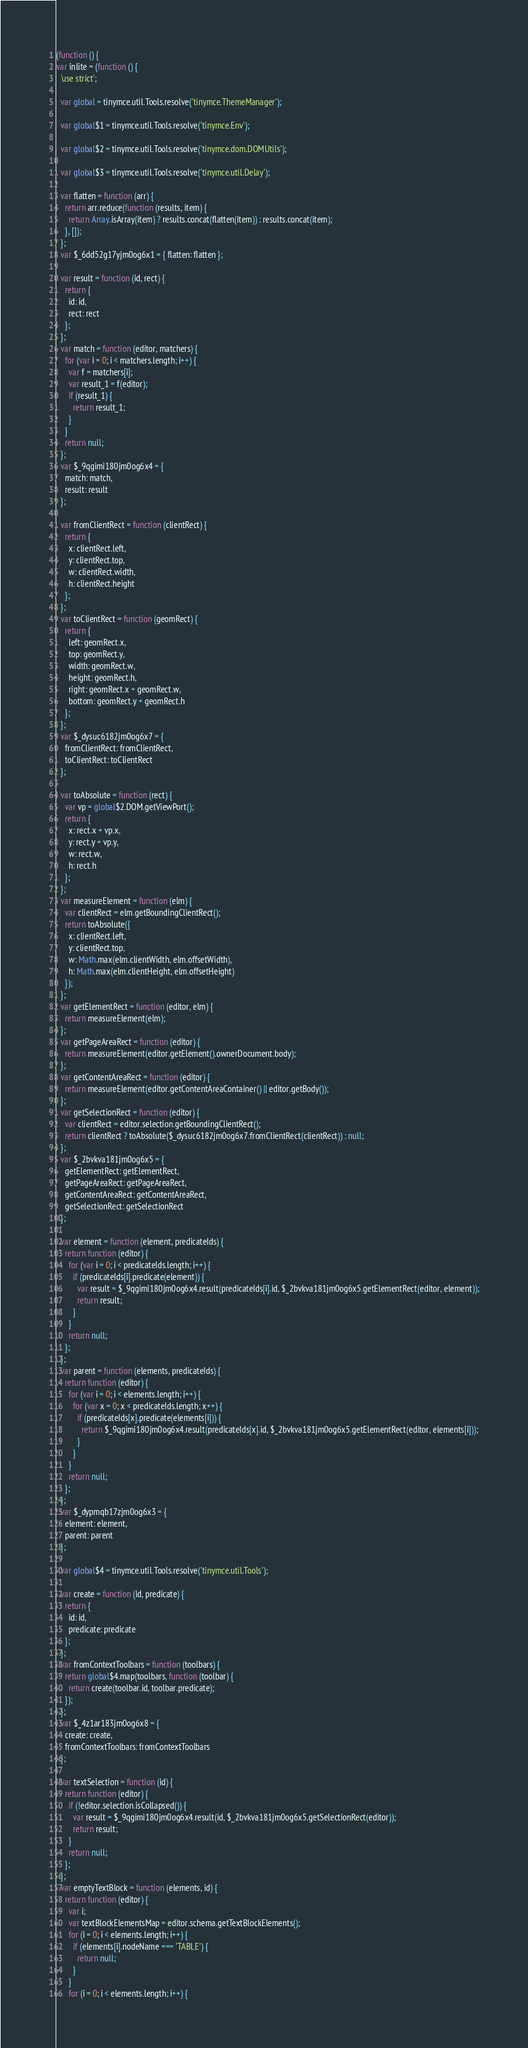Convert code to text. <code><loc_0><loc_0><loc_500><loc_500><_JavaScript_>(function () {
var inlite = (function () {
  'use strict';

  var global = tinymce.util.Tools.resolve('tinymce.ThemeManager');

  var global$1 = tinymce.util.Tools.resolve('tinymce.Env');

  var global$2 = tinymce.util.Tools.resolve('tinymce.dom.DOMUtils');

  var global$3 = tinymce.util.Tools.resolve('tinymce.util.Delay');

  var flatten = function (arr) {
    return arr.reduce(function (results, item) {
      return Array.isArray(item) ? results.concat(flatten(item)) : results.concat(item);
    }, []);
  };
  var $_6dd52g17yjm0og6x1 = { flatten: flatten };

  var result = function (id, rect) {
    return {
      id: id,
      rect: rect
    };
  };
  var match = function (editor, matchers) {
    for (var i = 0; i < matchers.length; i++) {
      var f = matchers[i];
      var result_1 = f(editor);
      if (result_1) {
        return result_1;
      }
    }
    return null;
  };
  var $_9qgimi180jm0og6x4 = {
    match: match,
    result: result
  };

  var fromClientRect = function (clientRect) {
    return {
      x: clientRect.left,
      y: clientRect.top,
      w: clientRect.width,
      h: clientRect.height
    };
  };
  var toClientRect = function (geomRect) {
    return {
      left: geomRect.x,
      top: geomRect.y,
      width: geomRect.w,
      height: geomRect.h,
      right: geomRect.x + geomRect.w,
      bottom: geomRect.y + geomRect.h
    };
  };
  var $_dysuc6182jm0og6x7 = {
    fromClientRect: fromClientRect,
    toClientRect: toClientRect
  };

  var toAbsolute = function (rect) {
    var vp = global$2.DOM.getViewPort();
    return {
      x: rect.x + vp.x,
      y: rect.y + vp.y,
      w: rect.w,
      h: rect.h
    };
  };
  var measureElement = function (elm) {
    var clientRect = elm.getBoundingClientRect();
    return toAbsolute({
      x: clientRect.left,
      y: clientRect.top,
      w: Math.max(elm.clientWidth, elm.offsetWidth),
      h: Math.max(elm.clientHeight, elm.offsetHeight)
    });
  };
  var getElementRect = function (editor, elm) {
    return measureElement(elm);
  };
  var getPageAreaRect = function (editor) {
    return measureElement(editor.getElement().ownerDocument.body);
  };
  var getContentAreaRect = function (editor) {
    return measureElement(editor.getContentAreaContainer() || editor.getBody());
  };
  var getSelectionRect = function (editor) {
    var clientRect = editor.selection.getBoundingClientRect();
    return clientRect ? toAbsolute($_dysuc6182jm0og6x7.fromClientRect(clientRect)) : null;
  };
  var $_2bvkva181jm0og6x5 = {
    getElementRect: getElementRect,
    getPageAreaRect: getPageAreaRect,
    getContentAreaRect: getContentAreaRect,
    getSelectionRect: getSelectionRect
  };

  var element = function (element, predicateIds) {
    return function (editor) {
      for (var i = 0; i < predicateIds.length; i++) {
        if (predicateIds[i].predicate(element)) {
          var result = $_9qgimi180jm0og6x4.result(predicateIds[i].id, $_2bvkva181jm0og6x5.getElementRect(editor, element));
          return result;
        }
      }
      return null;
    };
  };
  var parent = function (elements, predicateIds) {
    return function (editor) {
      for (var i = 0; i < elements.length; i++) {
        for (var x = 0; x < predicateIds.length; x++) {
          if (predicateIds[x].predicate(elements[i])) {
            return $_9qgimi180jm0og6x4.result(predicateIds[x].id, $_2bvkva181jm0og6x5.getElementRect(editor, elements[i]));
          }
        }
      }
      return null;
    };
  };
  var $_dypmqb17zjm0og6x3 = {
    element: element,
    parent: parent
  };

  var global$4 = tinymce.util.Tools.resolve('tinymce.util.Tools');

  var create = function (id, predicate) {
    return {
      id: id,
      predicate: predicate
    };
  };
  var fromContextToolbars = function (toolbars) {
    return global$4.map(toolbars, function (toolbar) {
      return create(toolbar.id, toolbar.predicate);
    });
  };
  var $_4z1ar183jm0og6x8 = {
    create: create,
    fromContextToolbars: fromContextToolbars
  };

  var textSelection = function (id) {
    return function (editor) {
      if (!editor.selection.isCollapsed()) {
        var result = $_9qgimi180jm0og6x4.result(id, $_2bvkva181jm0og6x5.getSelectionRect(editor));
        return result;
      }
      return null;
    };
  };
  var emptyTextBlock = function (elements, id) {
    return function (editor) {
      var i;
      var textBlockElementsMap = editor.schema.getTextBlockElements();
      for (i = 0; i < elements.length; i++) {
        if (elements[i].nodeName === 'TABLE') {
          return null;
        }
      }
      for (i = 0; i < elements.length; i++) {</code> 